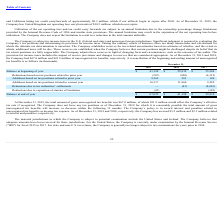According to Fitbit's financial document, Under the company's policy, what is recorded as income tax expense? Interest and penalties related to unrecognized tax benefits. The document states: "wing 12 months. The Company’s policy is to record interest and penalties related to unrecognized tax benefits as income tax expense. As of December 31..." Also, What is the amount related to interest and penalties as of December 31, 2018? According to the financial document, $3.1 million. The relevant text states: "ectively, the Company has accrued $5.2 million and $3.1 million related to interest and penalties, respectively...." Also, At what years is the Company in the United States under examination by the Internal Revenue Service? According to the financial document, fiscal 2015 to 2017. The relevant text states: "ation by the Internal Revenue Service ("IRS") for fiscal 2015 to 2017. For state and non-U.S. tax returns, the Company is generally no longer subject to tax examinations..." Also, can you calculate: What is the average additions based on tax positions related to prior year from 2017-2019? To answer this question, I need to perform calculations using the financial data. The calculation is: (9,562+263+108)/3, which equals 3311 (in thousands). This is based on the information: "on tax positions related to prior year 9,562 263 108 ions based on tax positions related to prior year 9,562 263 108 ased on tax positions related to prior year 9,562 263 108..." The key data points involved are: 108, 263, 9,562. Also, can you calculate: What is the difference in the balance at end of year between 2018 and 2019? Based on the calculation: 67,025-41,198, the result is 25827 (in thousands). This is based on the information: "Balance at end of year $ 67,025 $ 41,198 $ 29,938 Balance at beginning of year $ 41,198 $ 29,938 $ 35,584..." The key data points involved are: 41,198, 67,025. Also, can you calculate: What is the percentage change of additions based on tax positions related to current year from 2018 to 2019? To answer this question, I need to perform calculations using the financial data. The calculation is: (16,517-11,860)/11,860, which equals 39.27 (percentage). This is based on the information: "d on tax positions related to current year 16,517 11,860 9,289 ns based on tax positions related to current year 16,517 11,860 9,289..." The key data points involved are: 11,860, 16,517. 